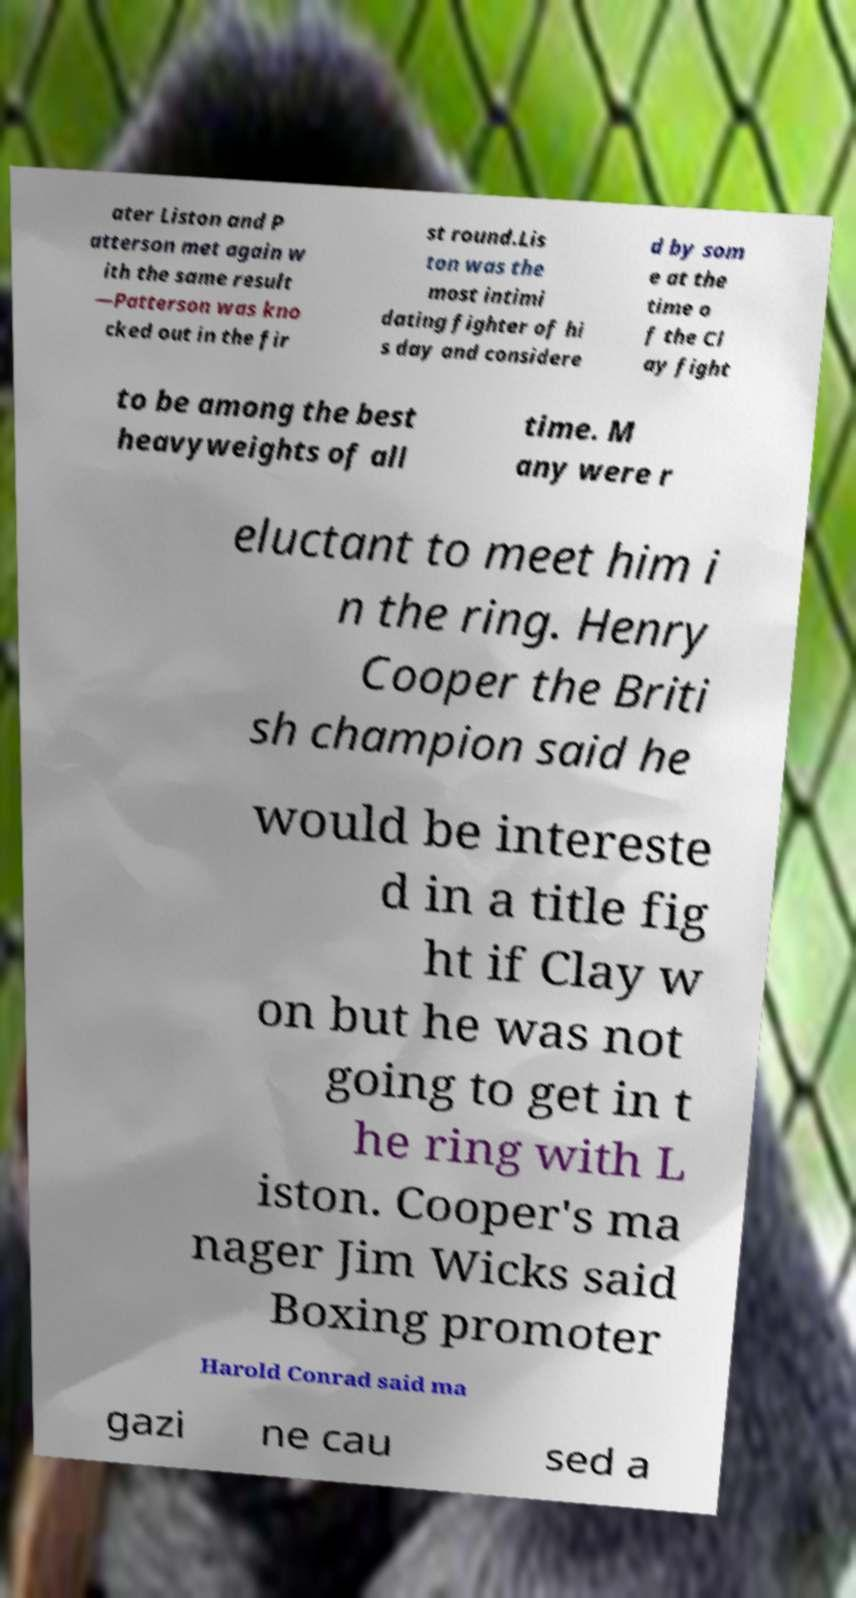Please identify and transcribe the text found in this image. ater Liston and P atterson met again w ith the same result —Patterson was kno cked out in the fir st round.Lis ton was the most intimi dating fighter of hi s day and considere d by som e at the time o f the Cl ay fight to be among the best heavyweights of all time. M any were r eluctant to meet him i n the ring. Henry Cooper the Briti sh champion said he would be intereste d in a title fig ht if Clay w on but he was not going to get in t he ring with L iston. Cooper's ma nager Jim Wicks said Boxing promoter Harold Conrad said ma gazi ne cau sed a 